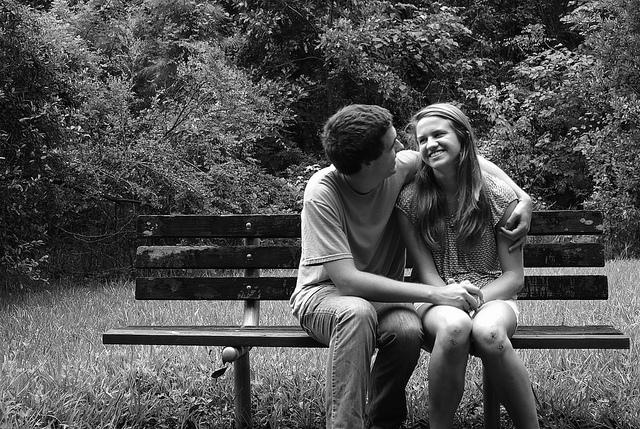Is this couple happy?
Short answer required. Yes. What is the couple sitting on?
Write a very short answer. Bench. Are the people have a happy conversation?
Short answer required. Yes. How many colors appear in this image?
Write a very short answer. 2. 